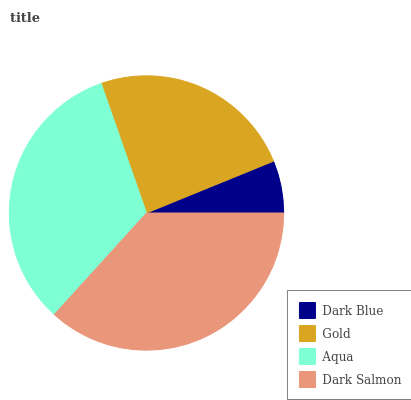Is Dark Blue the minimum?
Answer yes or no. Yes. Is Dark Salmon the maximum?
Answer yes or no. Yes. Is Gold the minimum?
Answer yes or no. No. Is Gold the maximum?
Answer yes or no. No. Is Gold greater than Dark Blue?
Answer yes or no. Yes. Is Dark Blue less than Gold?
Answer yes or no. Yes. Is Dark Blue greater than Gold?
Answer yes or no. No. Is Gold less than Dark Blue?
Answer yes or no. No. Is Aqua the high median?
Answer yes or no. Yes. Is Gold the low median?
Answer yes or no. Yes. Is Gold the high median?
Answer yes or no. No. Is Dark Blue the low median?
Answer yes or no. No. 